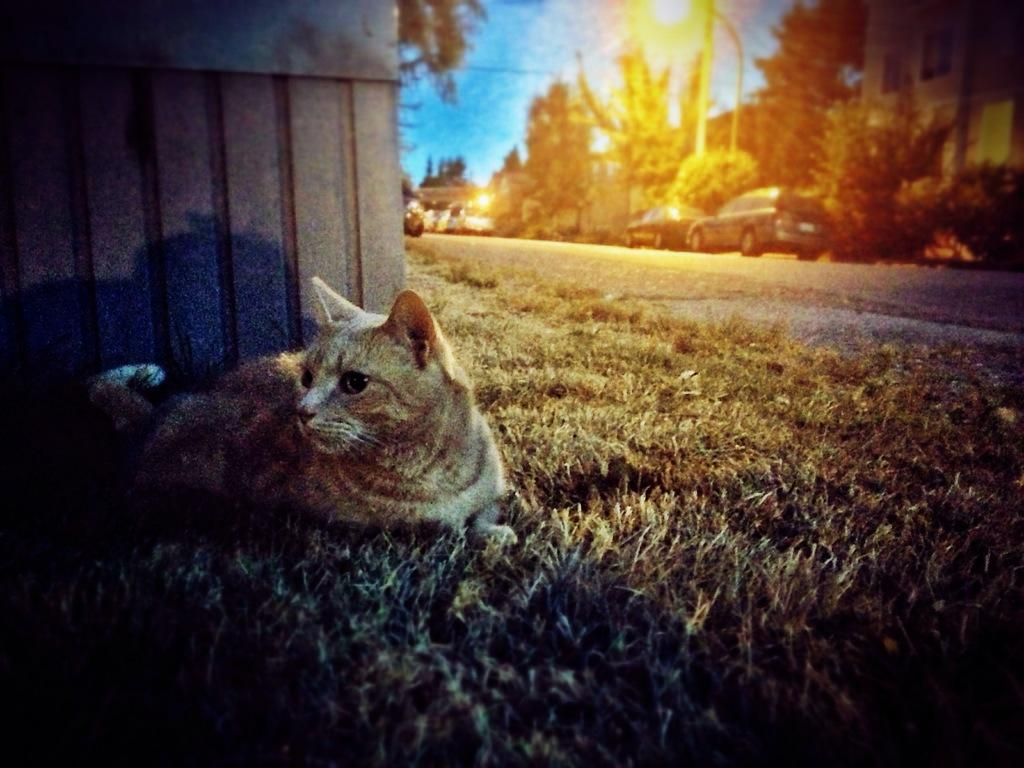What animal can be seen in the image? There is a cat in the image. Where is the cat located? The cat is on the grass. What can be seen in the background of the image? There are vehicles, a road, treehouses, lights, and a few objects in the background of the image. The sky is also visible. What type of cake is being served in the image? There is no cake present in the image; it features a cat on the grass and various elements in the background. Can you see a boot in the image? No, there is no boot visible in the image. 